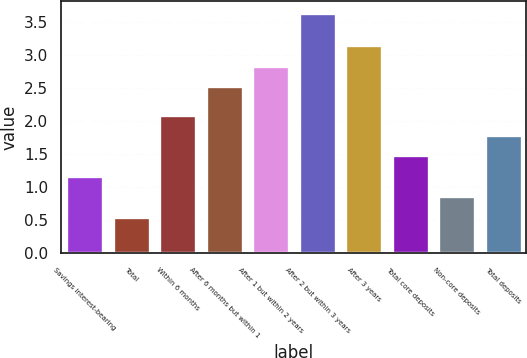Convert chart to OTSL. <chart><loc_0><loc_0><loc_500><loc_500><bar_chart><fcel>Savings interest-bearing<fcel>Total<fcel>Within 6 months<fcel>After 6 months but within 1<fcel>After 1 but within 2 years<fcel>After 2 but within 3 years<fcel>After 3 years<fcel>Total core deposits<fcel>Non-core deposits<fcel>Total deposits<nl><fcel>1.17<fcel>0.55<fcel>2.1<fcel>2.53<fcel>2.84<fcel>3.64<fcel>3.15<fcel>1.48<fcel>0.86<fcel>1.79<nl></chart> 